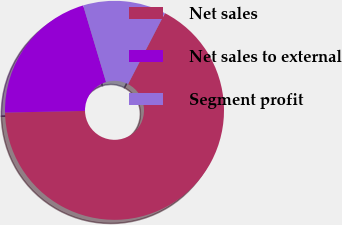Convert chart to OTSL. <chart><loc_0><loc_0><loc_500><loc_500><pie_chart><fcel>Net sales<fcel>Net sales to external<fcel>Segment profit<nl><fcel>67.06%<fcel>20.7%<fcel>12.24%<nl></chart> 